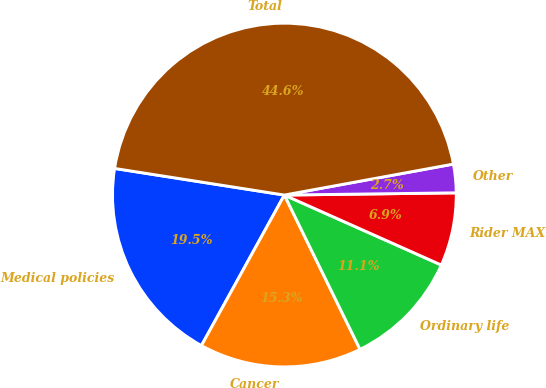<chart> <loc_0><loc_0><loc_500><loc_500><pie_chart><fcel>Medical policies<fcel>Cancer<fcel>Ordinary life<fcel>Rider MAX<fcel>Other<fcel>Total<nl><fcel>19.46%<fcel>15.27%<fcel>11.07%<fcel>6.88%<fcel>2.68%<fcel>44.64%<nl></chart> 